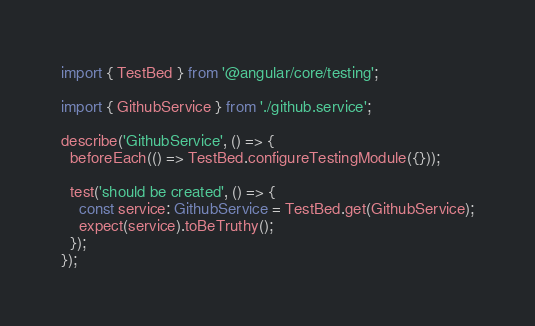<code> <loc_0><loc_0><loc_500><loc_500><_TypeScript_>import { TestBed } from '@angular/core/testing';

import { GithubService } from './github.service';

describe('GithubService', () => {
  beforeEach(() => TestBed.configureTestingModule({}));

  test('should be created', () => {
    const service: GithubService = TestBed.get(GithubService);
    expect(service).toBeTruthy();
  });
});
</code> 